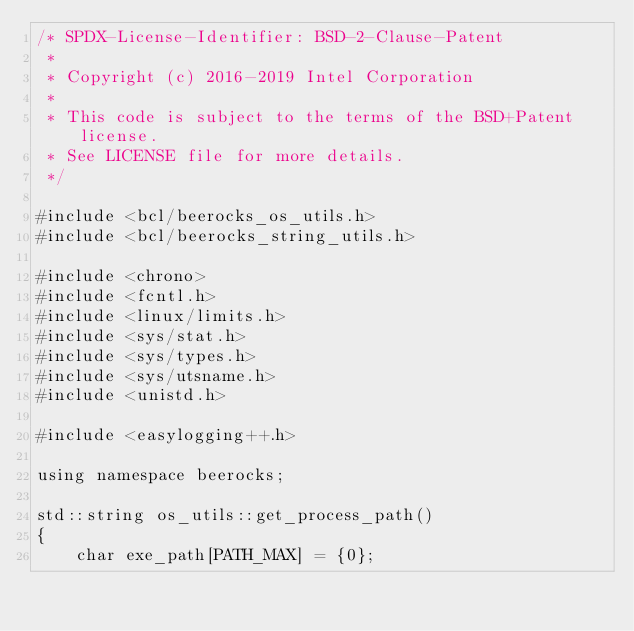<code> <loc_0><loc_0><loc_500><loc_500><_C++_>/* SPDX-License-Identifier: BSD-2-Clause-Patent
 *
 * Copyright (c) 2016-2019 Intel Corporation
 *
 * This code is subject to the terms of the BSD+Patent license.
 * See LICENSE file for more details.
 */

#include <bcl/beerocks_os_utils.h>
#include <bcl/beerocks_string_utils.h>

#include <chrono>
#include <fcntl.h>
#include <linux/limits.h>
#include <sys/stat.h>
#include <sys/types.h>
#include <sys/utsname.h>
#include <unistd.h>

#include <easylogging++.h>

using namespace beerocks;

std::string os_utils::get_process_path()
{
    char exe_path[PATH_MAX] = {0};</code> 